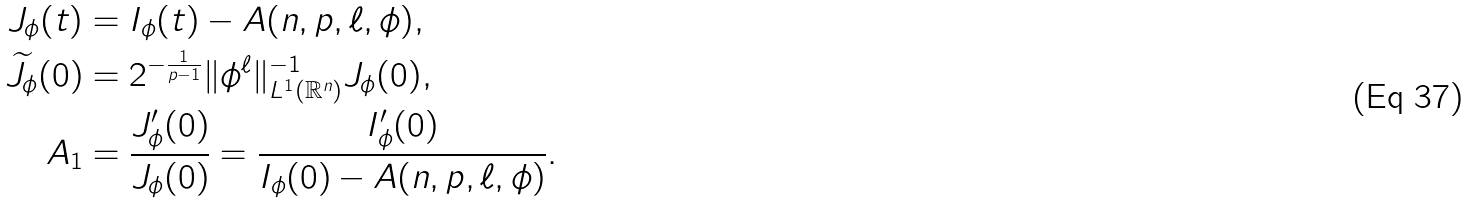<formula> <loc_0><loc_0><loc_500><loc_500>J _ { \phi } ( t ) & = I _ { \phi } ( t ) - A ( n , p , \ell , \phi ) , \\ \widetilde { J } _ { \phi } ( 0 ) & = 2 ^ { - \frac { 1 } { p - 1 } } \| \phi ^ { \ell } \| _ { L ^ { 1 } ( \mathbb { R } ^ { n } ) } ^ { - 1 } J _ { \phi } ( 0 ) , \\ A _ { 1 } & = \frac { J _ { \phi } ^ { \prime } ( 0 ) } { J _ { \phi } ( 0 ) } = \frac { I _ { \phi } ^ { \prime } ( 0 ) } { I _ { \phi } ( 0 ) - A ( n , p , \ell , \phi ) } .</formula> 